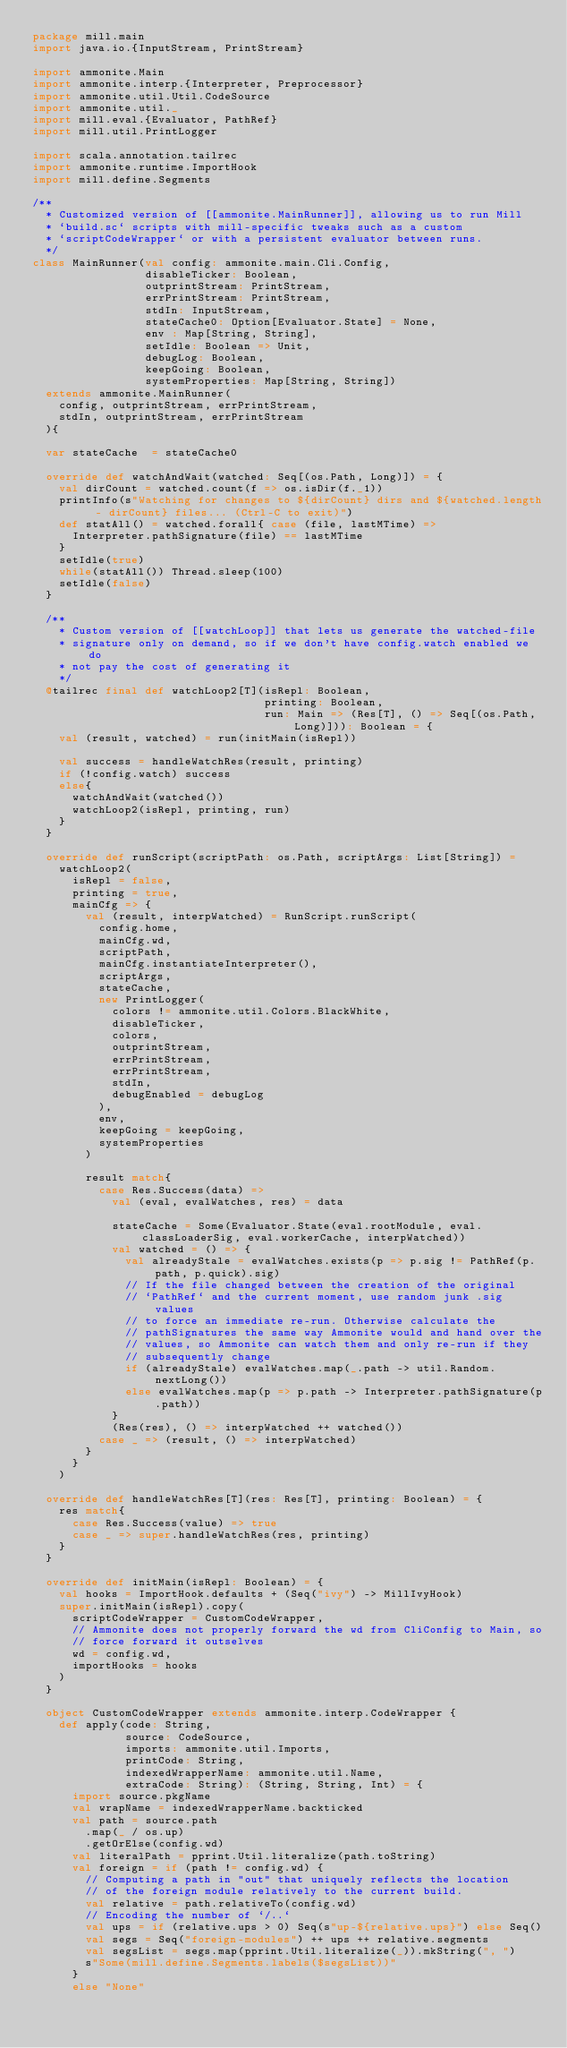<code> <loc_0><loc_0><loc_500><loc_500><_Scala_>package mill.main
import java.io.{InputStream, PrintStream}

import ammonite.Main
import ammonite.interp.{Interpreter, Preprocessor}
import ammonite.util.Util.CodeSource
import ammonite.util._
import mill.eval.{Evaluator, PathRef}
import mill.util.PrintLogger

import scala.annotation.tailrec
import ammonite.runtime.ImportHook
import mill.define.Segments

/**
  * Customized version of [[ammonite.MainRunner]], allowing us to run Mill
  * `build.sc` scripts with mill-specific tweaks such as a custom
  * `scriptCodeWrapper` or with a persistent evaluator between runs.
  */
class MainRunner(val config: ammonite.main.Cli.Config,
                 disableTicker: Boolean,
                 outprintStream: PrintStream,
                 errPrintStream: PrintStream,
                 stdIn: InputStream,
                 stateCache0: Option[Evaluator.State] = None,
                 env : Map[String, String],
                 setIdle: Boolean => Unit,
                 debugLog: Boolean,
                 keepGoing: Boolean,
                 systemProperties: Map[String, String])
  extends ammonite.MainRunner(
    config, outprintStream, errPrintStream,
    stdIn, outprintStream, errPrintStream
  ){

  var stateCache  = stateCache0

  override def watchAndWait(watched: Seq[(os.Path, Long)]) = {
    val dirCount = watched.count(f => os.isDir(f._1))
    printInfo(s"Watching for changes to ${dirCount} dirs and ${watched.length - dirCount} files... (Ctrl-C to exit)")
    def statAll() = watched.forall{ case (file, lastMTime) =>
      Interpreter.pathSignature(file) == lastMTime
    }
    setIdle(true)
    while(statAll()) Thread.sleep(100)
    setIdle(false)
  }

  /**
    * Custom version of [[watchLoop]] that lets us generate the watched-file
    * signature only on demand, so if we don't have config.watch enabled we do
    * not pay the cost of generating it
    */
  @tailrec final def watchLoop2[T](isRepl: Boolean,
                                   printing: Boolean,
                                   run: Main => (Res[T], () => Seq[(os.Path, Long)])): Boolean = {
    val (result, watched) = run(initMain(isRepl))

    val success = handleWatchRes(result, printing)
    if (!config.watch) success
    else{
      watchAndWait(watched())
      watchLoop2(isRepl, printing, run)
    }
  }

  override def runScript(scriptPath: os.Path, scriptArgs: List[String]) =
    watchLoop2(
      isRepl = false,
      printing = true,
      mainCfg => {
        val (result, interpWatched) = RunScript.runScript(
          config.home,
          mainCfg.wd,
          scriptPath,
          mainCfg.instantiateInterpreter(),
          scriptArgs,
          stateCache,
          new PrintLogger(
            colors != ammonite.util.Colors.BlackWhite,
            disableTicker,
            colors,
            outprintStream,
            errPrintStream,
            errPrintStream,
            stdIn,
            debugEnabled = debugLog
          ),
          env,
          keepGoing = keepGoing,
          systemProperties
        )

        result match{
          case Res.Success(data) =>
            val (eval, evalWatches, res) = data

            stateCache = Some(Evaluator.State(eval.rootModule, eval.classLoaderSig, eval.workerCache, interpWatched))
            val watched = () => {
              val alreadyStale = evalWatches.exists(p => p.sig != PathRef(p.path, p.quick).sig)
              // If the file changed between the creation of the original
              // `PathRef` and the current moment, use random junk .sig values
              // to force an immediate re-run. Otherwise calculate the
              // pathSignatures the same way Ammonite would and hand over the
              // values, so Ammonite can watch them and only re-run if they
              // subsequently change
              if (alreadyStale) evalWatches.map(_.path -> util.Random.nextLong())
              else evalWatches.map(p => p.path -> Interpreter.pathSignature(p.path))
            }
            (Res(res), () => interpWatched ++ watched())
          case _ => (result, () => interpWatched)
        }
      }
    )

  override def handleWatchRes[T](res: Res[T], printing: Boolean) = {
    res match{
      case Res.Success(value) => true
      case _ => super.handleWatchRes(res, printing)
    }
  }

  override def initMain(isRepl: Boolean) = {
    val hooks = ImportHook.defaults + (Seq("ivy") -> MillIvyHook)
    super.initMain(isRepl).copy(
      scriptCodeWrapper = CustomCodeWrapper,
      // Ammonite does not properly forward the wd from CliConfig to Main, so
      // force forward it outselves
      wd = config.wd,
      importHooks = hooks
    )
  }

  object CustomCodeWrapper extends ammonite.interp.CodeWrapper {
    def apply(code: String,
              source: CodeSource,
              imports: ammonite.util.Imports,
              printCode: String,
              indexedWrapperName: ammonite.util.Name,
              extraCode: String): (String, String, Int) = {
      import source.pkgName
      val wrapName = indexedWrapperName.backticked
      val path = source.path
        .map(_ / os.up)
        .getOrElse(config.wd)
      val literalPath = pprint.Util.literalize(path.toString)
      val foreign = if (path != config.wd) {
        // Computing a path in "out" that uniquely reflects the location
        // of the foreign module relatively to the current build.
        val relative = path.relativeTo(config.wd)
        // Encoding the number of `/..`
        val ups = if (relative.ups > 0) Seq(s"up-${relative.ups}") else Seq()
        val segs = Seq("foreign-modules") ++ ups ++ relative.segments
        val segsList = segs.map(pprint.Util.literalize(_)).mkString(", ")
        s"Some(mill.define.Segments.labels($segsList))"
      }
      else "None"
</code> 